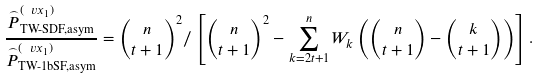<formula> <loc_0><loc_0><loc_500><loc_500>\frac { \stackrel { _ { \frown } } { P } ^ { ( \ v x _ { 1 } ) } _ { \text {TW-SDF,asym} } } { \stackrel { _ { \frown } } { P } ^ { ( \ v x _ { 1 } ) } _ { \text {TW-1bSF,asym} } } = \binom { n } { t + 1 } ^ { 2 } / \left [ \binom { n } { t + 1 } ^ { 2 } - \sum _ { k = 2 t + 1 } ^ { n } W _ { k } \left ( \binom { n } { t + 1 } - \binom { k } { t + 1 } \right ) \right ] .</formula> 